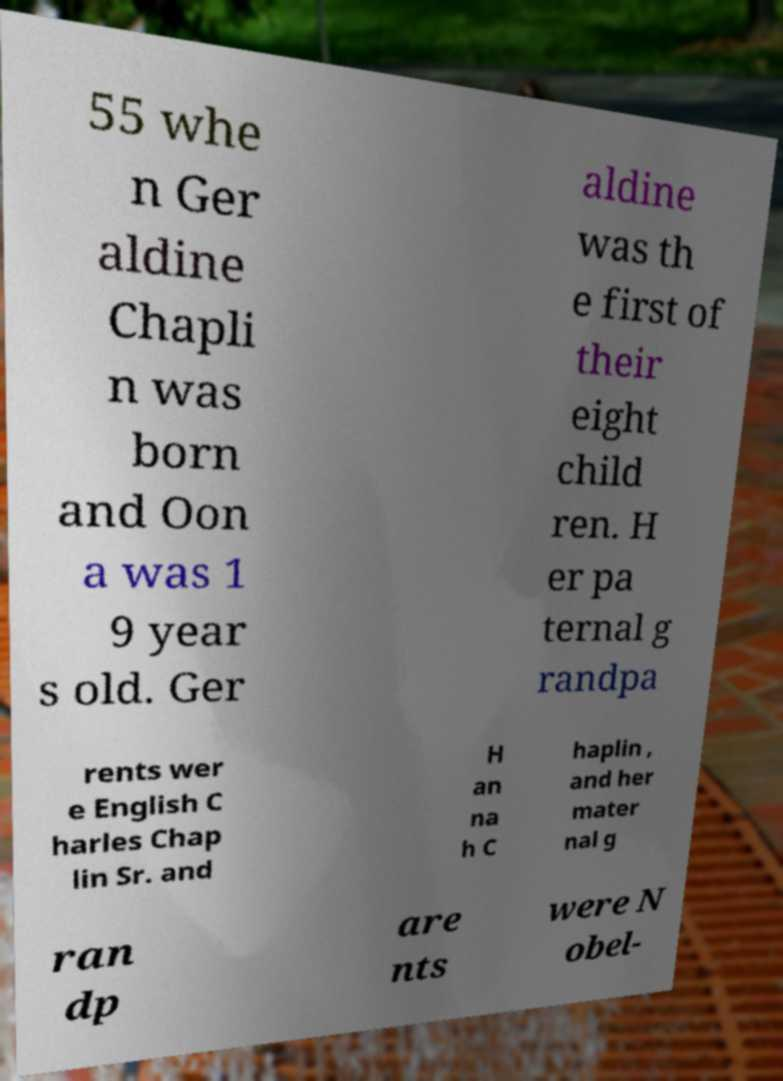For documentation purposes, I need the text within this image transcribed. Could you provide that? 55 whe n Ger aldine Chapli n was born and Oon a was 1 9 year s old. Ger aldine was th e first of their eight child ren. H er pa ternal g randpa rents wer e English C harles Chap lin Sr. and H an na h C haplin , and her mater nal g ran dp are nts were N obel- 